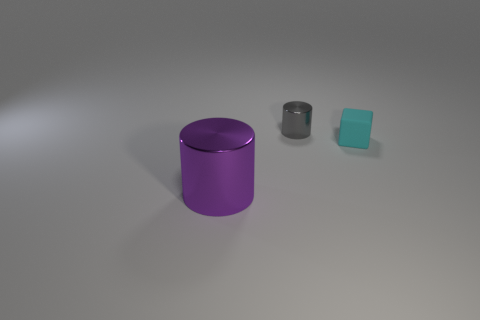Add 3 purple cylinders. How many objects exist? 6 Subtract all purple cylinders. How many cylinders are left? 1 Subtract all green blocks. How many purple cylinders are left? 1 Subtract all brown cylinders. Subtract all purple blocks. How many cylinders are left? 2 Subtract all small blocks. Subtract all small blue metallic cylinders. How many objects are left? 2 Add 2 tiny gray objects. How many tiny gray objects are left? 3 Add 3 purple metallic objects. How many purple metallic objects exist? 4 Subtract 0 blue cylinders. How many objects are left? 3 Subtract all cubes. How many objects are left? 2 